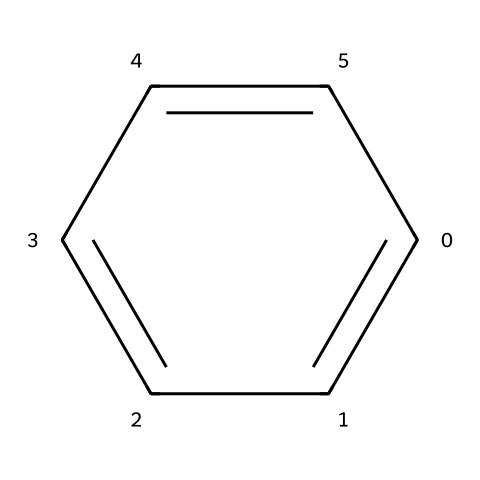What is the molecular formula of this chemical? The chemical structure represents benzene, which can be broken down into its elemental components: it has six carbon atoms and six hydrogen atoms. Therefore, the molecular formula is C6H6.
Answer: C6H6 How many carbon atoms are in the structure? A count of the carbon atoms in the benzene structure reveals that there are six carbon atoms present, each represented at the corners of a hexagonal ring.
Answer: 6 What type of chemical compound is this? Benzene is classified specifically as an aromatic hydrocarbon due to its ring structure and delocalized pi electrons, which give it unique stability and reactivity.
Answer: aromatic hydrocarbon What type of bond is primarily present in this chemical? The chemical structure shows that the bonds between the carbon atoms are primarily covalent bonds, as they share electrons to form stable connections.
Answer: covalent How does the structure of this chemical contribute to its toxicity? The chemical structure of benzene, which exhibits a stable ring and delocalized electrons, makes it resistant to breakdown and can lead to long-term accumulation in the environment and biological systems, potentially causing health issues like cancer.
Answer: stable ring structure What is the shape of the benzene molecule? Benzene has a planar, hexagonal structure formed by its carbon atoms arranged in a cyclic manner, all in the same plane, which is characteristic of aromatic compounds.
Answer: planar hexagonal What properties result from the delocalization of electrons in this chemical? The delocalization of electrons in benzene contributes to its stability and unique aromatic properties, allowing it to resist reactions that would normally occur with aliphatic compounds. This stability also leads to its persistence in the environment.
Answer: stability and persistence 